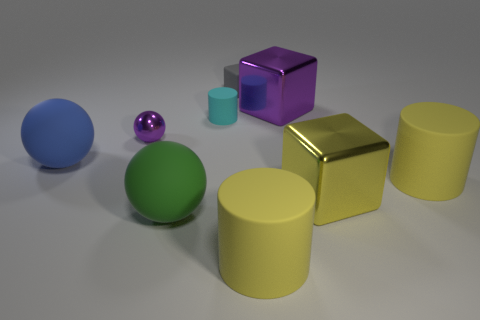There is a thing that is the same color as the small sphere; what size is it?
Ensure brevity in your answer.  Large. Are the large yellow thing behind the yellow block and the large blue sphere made of the same material?
Make the answer very short. Yes. Are there any small matte cylinders of the same color as the tiny cube?
Give a very brief answer. No. Is the shape of the metallic object that is behind the tiny purple sphere the same as the yellow rubber object behind the green ball?
Keep it short and to the point. No. Are there any large green balls made of the same material as the small cyan object?
Provide a succinct answer. Yes. What number of gray objects are either matte things or small cylinders?
Give a very brief answer. 1. How big is the object that is both right of the big green rubber object and on the left side of the small block?
Provide a succinct answer. Small. Is the number of cylinders that are on the right side of the rubber cube greater than the number of metallic cubes?
Provide a succinct answer. No. How many spheres are either blue things or small cyan objects?
Offer a very short reply. 1. There is a large rubber object that is right of the cyan matte cylinder and to the left of the yellow shiny thing; what is its shape?
Make the answer very short. Cylinder. 